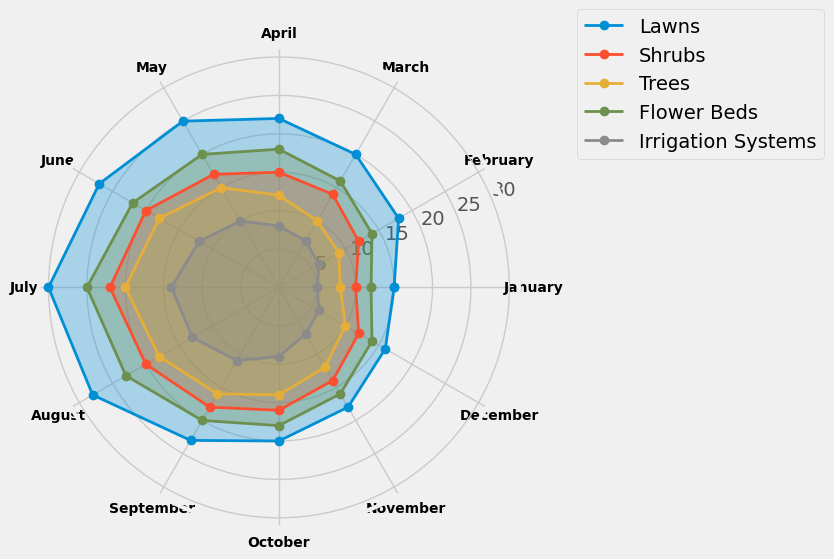What is the average number of recommendations for Flower Beds in the first three months? Sum of the recommendations for Flower Beds in January, February, and March is 12 + 14 + 16 = 42. The average is 42 / 3 = 14
Answer: 14 During which month are recommendations for Trees highest? By comparing the values for each month related to Trees, the highest number of recommendations is in July where the value is 20
Answer: July How does the number of recommendations for Irrigation Systems in March compare to the recommendations for Shrubs in May? The number of recommendations for Irrigation Systems in March is 7 and for Shrubs in May is 17. 7 is less than 17
Answer: Less Which product type shows the greatest variability in recommendations? By visually comparing the breadth of the radar chart for each product type, Lawns shows the greatest variability with values ranging from 15 to 30
Answer: Lawns What is the median value of recommendations for Shrubs across all months? The sorted recommendations for Shrubs are 10, 12, 12, 14, 14, 15, 16, 17, 18, 20, 20, 22. The median is the average of the two middle numbers (15 and 16): (15 + 16) / 2 = 15.5
Answer: 15.5 Which product type is recommended least frequently during the summer months (June, July, August)? By visually inspecting the radar chart, Irrigation Systems have the lowest values (12, 14, 13) compared to all other product types
Answer: Irrigation Systems How does the number of recommendations for Flower Beds in August compare to the number for Shrubs in August? The number of recommendations for Flower Beds in August is 23, and for Shrubs in August is 20. 23 is greater than 20
Answer: Greater What's the difference in recommendation frequencies between Lawns and Trees in October? The number of recommendations for Lawns in October is 20, and for Trees, it is 14. The difference is 20 - 14 = 6
Answer: 6 By how much do recommendations for Lawns increase from March to June? The number of recommendations for Lawns in March is 20, and in June is 27. The increase is 27 - 20 = 7
Answer: 7 